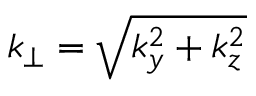Convert formula to latex. <formula><loc_0><loc_0><loc_500><loc_500>k _ { \perp } = \sqrt { k _ { y } ^ { 2 } + k _ { z } ^ { 2 } }</formula> 